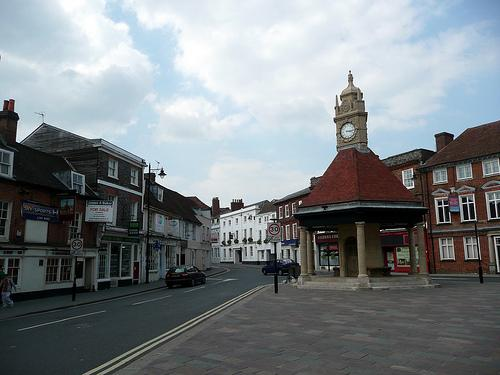List three prominent objects or elements in the image and a detail about each. 1. Clock tower with red roof, 2. Street lined with buildings, some white with white windows, 3. Two cars on street, one dark and the other blue. Identify the central focus of the image and describe it in a sentence. The central focus is the clock tower structure in the town square with a white clock and red roof. Describe any outdoor decoration or structure present in the image. There is a gazebo with a clock on top near the clock tower in the city square. Mention one unique characteristic of the buildings in the image. Several of the buildings have white facades and windows, contrasting with the colonial brick structures. Mention the overall atmosphere and weather in the image. The image has a busy, urban atmosphere with a partially cloudy blue sky overhead. Provide a brief description of the scene depicted in the image. A city square with two cars on the street, a man walking, a clock tower, cloud-filled sky, and white and brick buildings with signs. Briefly describe the setting and activities taking place in the image. In a bustling city square, cars travel down the street, people walk on the sidewalks, and buildings stand shoulder to shoulder beneath a partly cloudy sky. Explain the main type of transportation visible in the image. Cars are the main type of transportation visible, with two seen parked or turning on the street. Describe the day's weather, as seen in the image. The weather appears to be partly cloudy with visible blue sky amidst the clouds. In one sentence, describe the most distinct object or feature in the image. The red-roofed clock tower with a white clock is the most distinct feature in the image. 